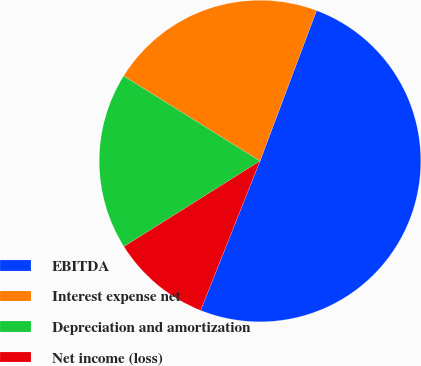<chart> <loc_0><loc_0><loc_500><loc_500><pie_chart><fcel>EBITDA<fcel>Interest expense net<fcel>Depreciation and amortization<fcel>Net income (loss)<nl><fcel>50.3%<fcel>21.84%<fcel>17.81%<fcel>10.04%<nl></chart> 